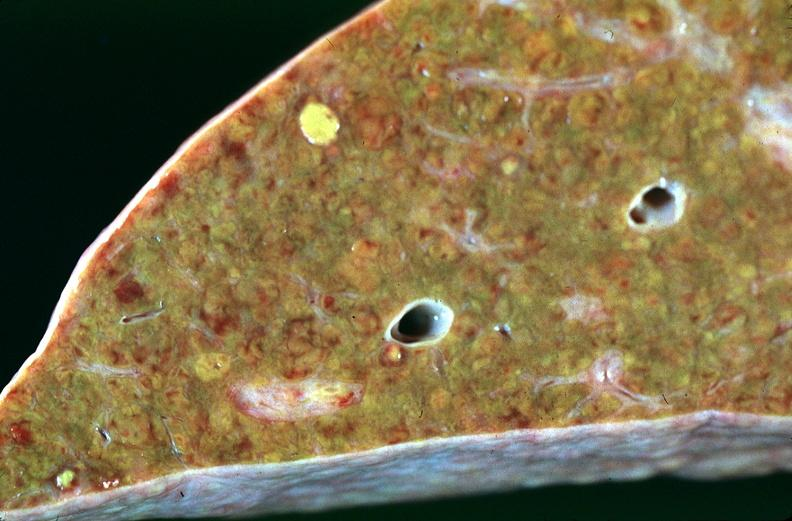s hepatobiliary present?
Answer the question using a single word or phrase. Yes 